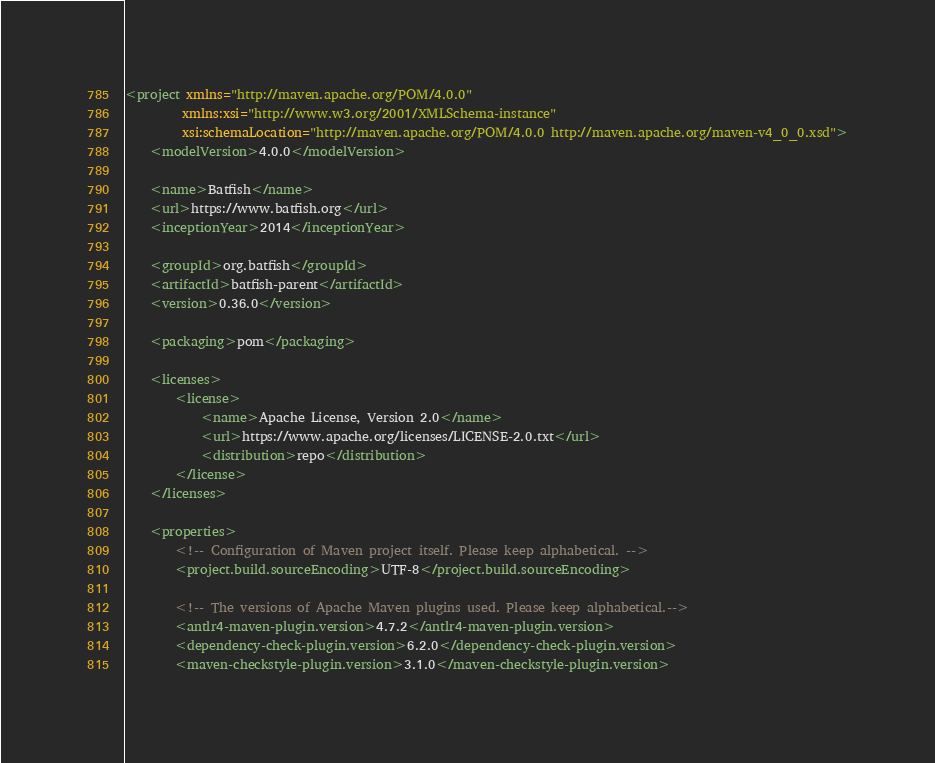<code> <loc_0><loc_0><loc_500><loc_500><_XML_><project xmlns="http://maven.apache.org/POM/4.0.0"
         xmlns:xsi="http://www.w3.org/2001/XMLSchema-instance"
         xsi:schemaLocation="http://maven.apache.org/POM/4.0.0 http://maven.apache.org/maven-v4_0_0.xsd">
    <modelVersion>4.0.0</modelVersion>

    <name>Batfish</name>
    <url>https://www.batfish.org</url>
    <inceptionYear>2014</inceptionYear>

    <groupId>org.batfish</groupId>
    <artifactId>batfish-parent</artifactId>
    <version>0.36.0</version>

    <packaging>pom</packaging>

    <licenses>
        <license>
            <name>Apache License, Version 2.0</name>
            <url>https://www.apache.org/licenses/LICENSE-2.0.txt</url>
            <distribution>repo</distribution>
        </license>
    </licenses>

    <properties>
        <!-- Configuration of Maven project itself. Please keep alphabetical. -->
        <project.build.sourceEncoding>UTF-8</project.build.sourceEncoding>

        <!-- The versions of Apache Maven plugins used. Please keep alphabetical.-->
        <antlr4-maven-plugin.version>4.7.2</antlr4-maven-plugin.version>
        <dependency-check-plugin.version>6.2.0</dependency-check-plugin.version>
        <maven-checkstyle-plugin.version>3.1.0</maven-checkstyle-plugin.version></code> 